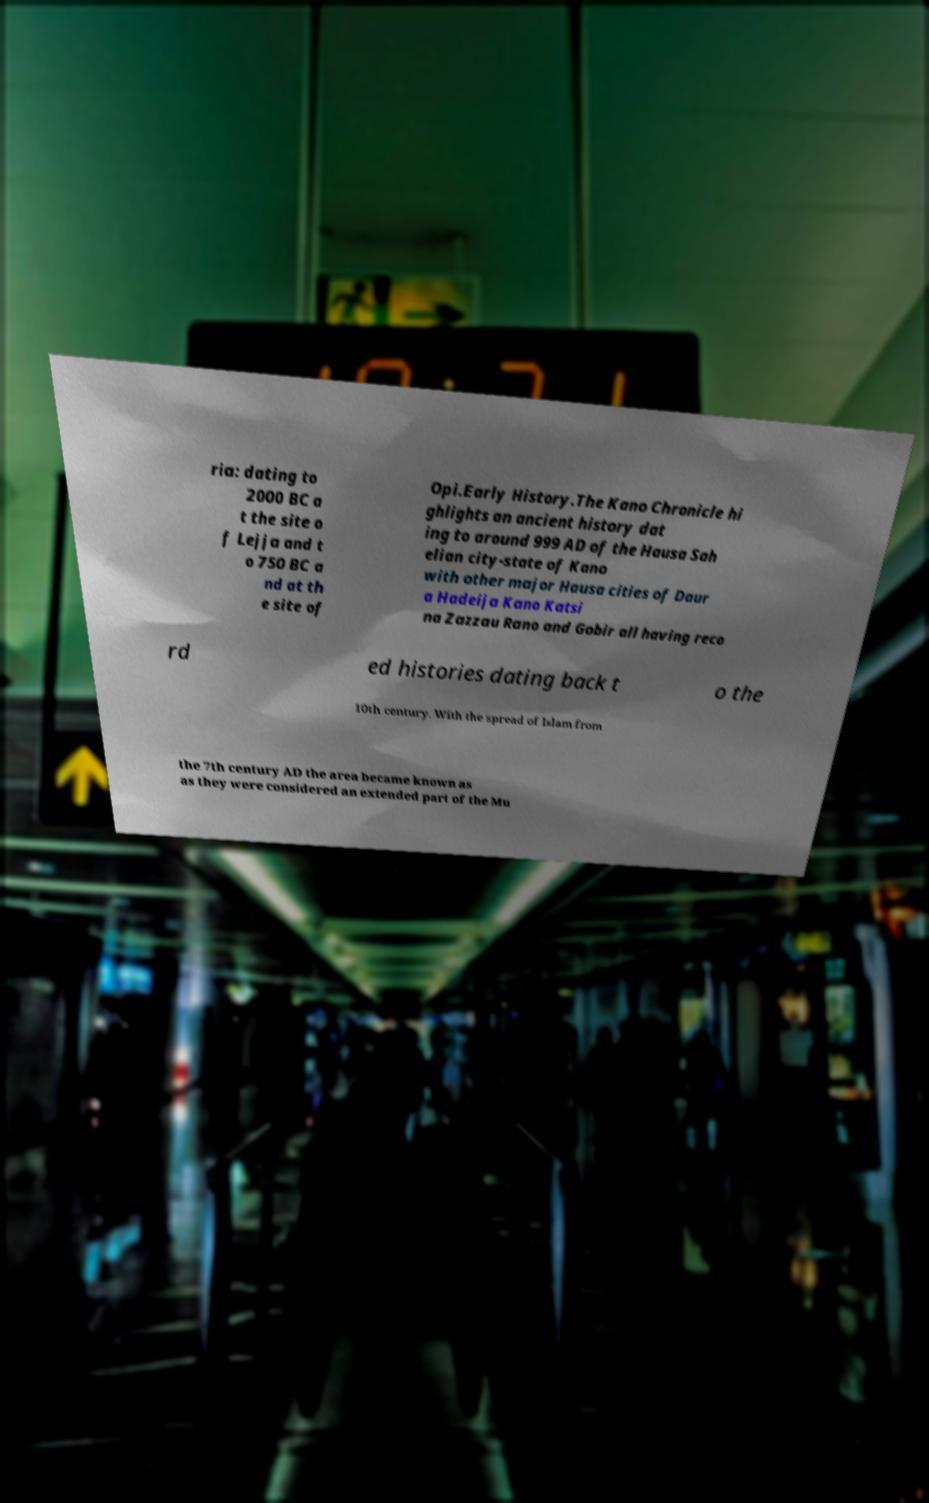Could you assist in decoding the text presented in this image and type it out clearly? ria: dating to 2000 BC a t the site o f Lejja and t o 750 BC a nd at th e site of Opi.Early History.The Kano Chronicle hi ghlights an ancient history dat ing to around 999 AD of the Hausa Sah elian city-state of Kano with other major Hausa cities of Daur a Hadeija Kano Katsi na Zazzau Rano and Gobir all having reco rd ed histories dating back t o the 10th century. With the spread of Islam from the 7th century AD the area became known as as they were considered an extended part of the Mu 